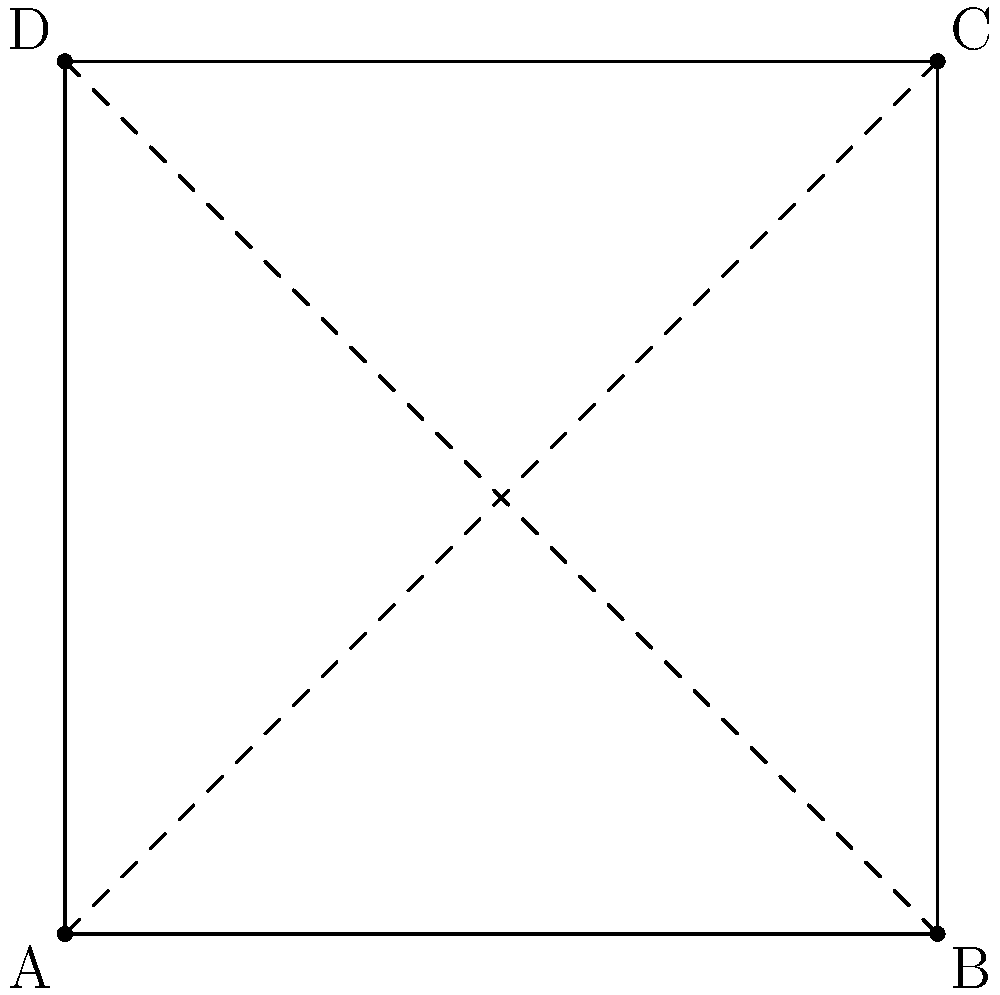Look at this simple square shape. How many ways can you rotate it so that it looks exactly the same as it did before? Let's think about this step-by-step:

1. First, we need to understand what "looks exactly the same" means. It means that after rotation, each corner should be in a position where a corner was before.

2. Now, let's try different rotations:
   a) If we don't rotate at all (0 degrees), it looks the same. This counts as one way.
   b) If we rotate by 90 degrees clockwise, it looks the same. This is the second way.
   c) If we rotate by 180 degrees, it looks the same. This is the third way.
   d) If we rotate by 270 degrees clockwise (or 90 degrees counterclockwise), it looks the same. This is the fourth way.

3. If we rotate by any other amount, the square won't look the same as it did before.

4. Therefore, there are 4 ways to rotate the square so that it looks exactly the same as it did before.

This property is called rotational symmetry, and we say that a square has 4-fold rotational symmetry.
Answer: 4 ways 